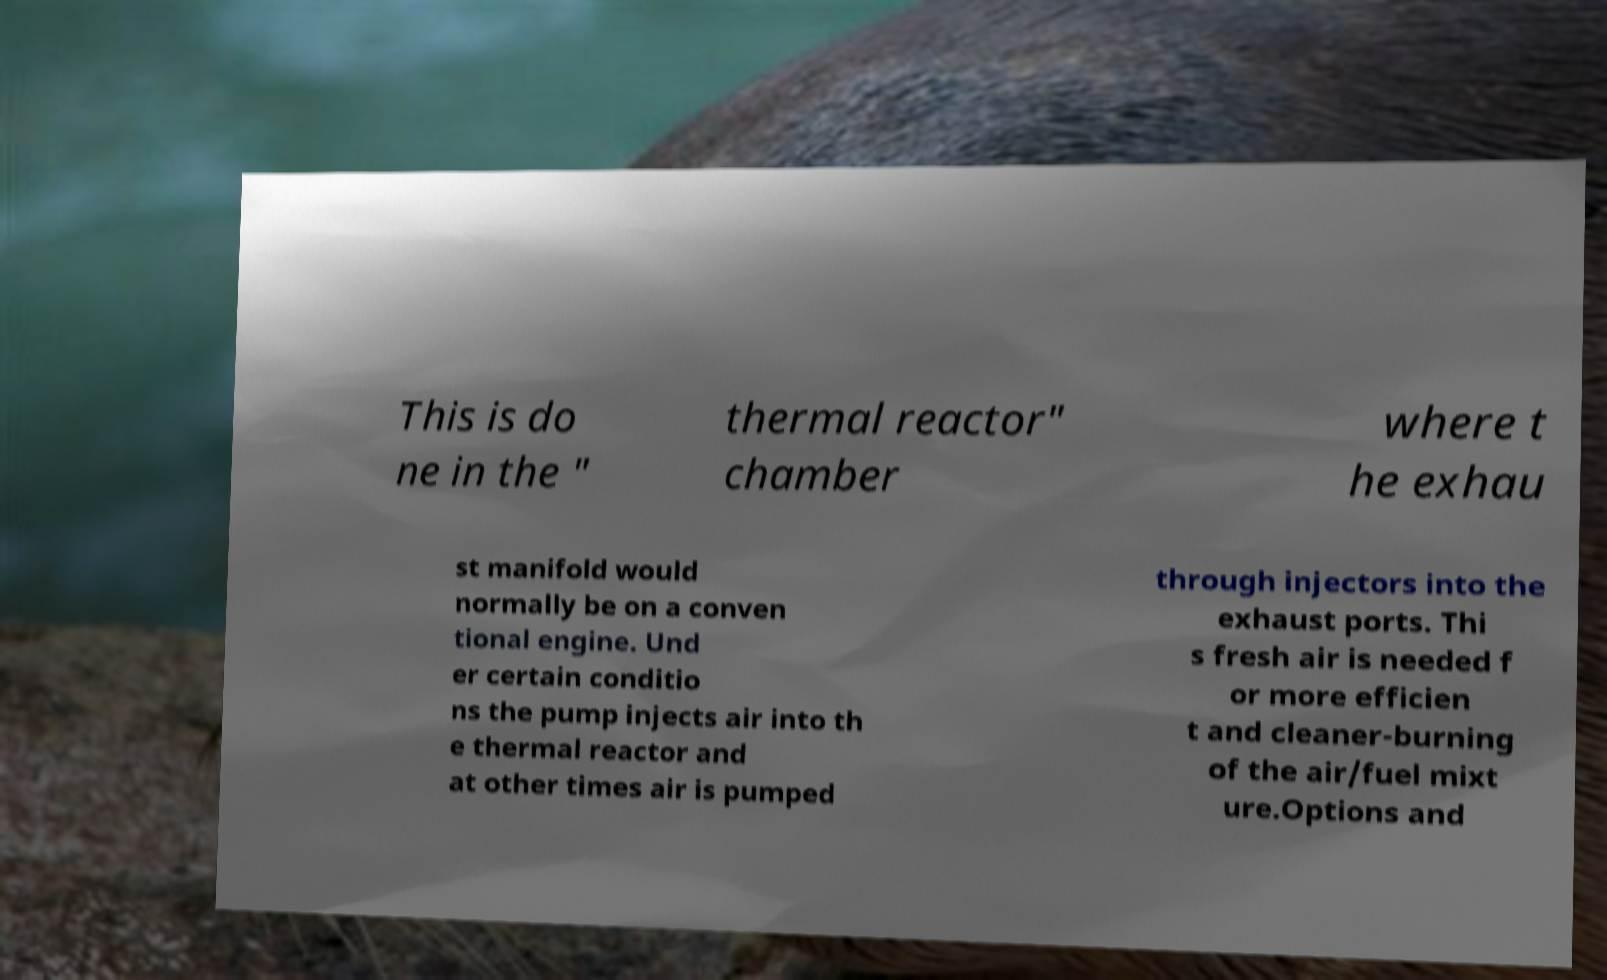For documentation purposes, I need the text within this image transcribed. Could you provide that? This is do ne in the " thermal reactor" chamber where t he exhau st manifold would normally be on a conven tional engine. Und er certain conditio ns the pump injects air into th e thermal reactor and at other times air is pumped through injectors into the exhaust ports. Thi s fresh air is needed f or more efficien t and cleaner-burning of the air/fuel mixt ure.Options and 